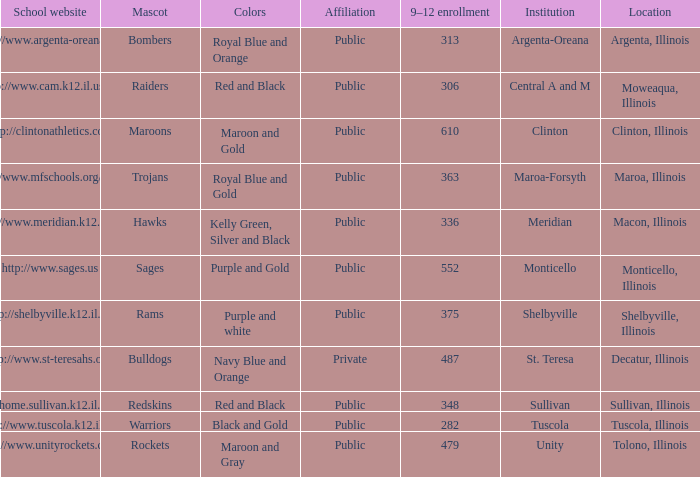What venue has 363 students attending the 9th to 12th grades? Maroa, Illinois. Write the full table. {'header': ['School website', 'Mascot', 'Colors', 'Affiliation', '9–12 enrollment', 'Institution', 'Location'], 'rows': [['http://www.argenta-oreana.org', 'Bombers', 'Royal Blue and Orange', 'Public', '313', 'Argenta-Oreana', 'Argenta, Illinois'], ['http://www.cam.k12.il.us/hs', 'Raiders', 'Red and Black', 'Public', '306', 'Central A and M', 'Moweaqua, Illinois'], ['http://clintonathletics.com', 'Maroons', 'Maroon and Gold', 'Public', '610', 'Clinton', 'Clinton, Illinois'], ['http://www.mfschools.org/high/', 'Trojans', 'Royal Blue and Gold', 'Public', '363', 'Maroa-Forsyth', 'Maroa, Illinois'], ['http://www.meridian.k12.il.us/', 'Hawks', 'Kelly Green, Silver and Black', 'Public', '336', 'Meridian', 'Macon, Illinois'], ['http://www.sages.us', 'Sages', 'Purple and Gold', 'Public', '552', 'Monticello', 'Monticello, Illinois'], ['http://shelbyville.k12.il.us/', 'Rams', 'Purple and white', 'Public', '375', 'Shelbyville', 'Shelbyville, Illinois'], ['http://www.st-teresahs.org/', 'Bulldogs', 'Navy Blue and Orange', 'Private', '487', 'St. Teresa', 'Decatur, Illinois'], ['http://home.sullivan.k12.il.us/shs', 'Redskins', 'Red and Black', 'Public', '348', 'Sullivan', 'Sullivan, Illinois'], ['http://www.tuscola.k12.il.us/', 'Warriors', 'Black and Gold', 'Public', '282', 'Tuscola', 'Tuscola, Illinois'], ['http://www.unityrockets.com/', 'Rockets', 'Maroon and Gray', 'Public', '479', 'Unity', 'Tolono, Illinois']]} 